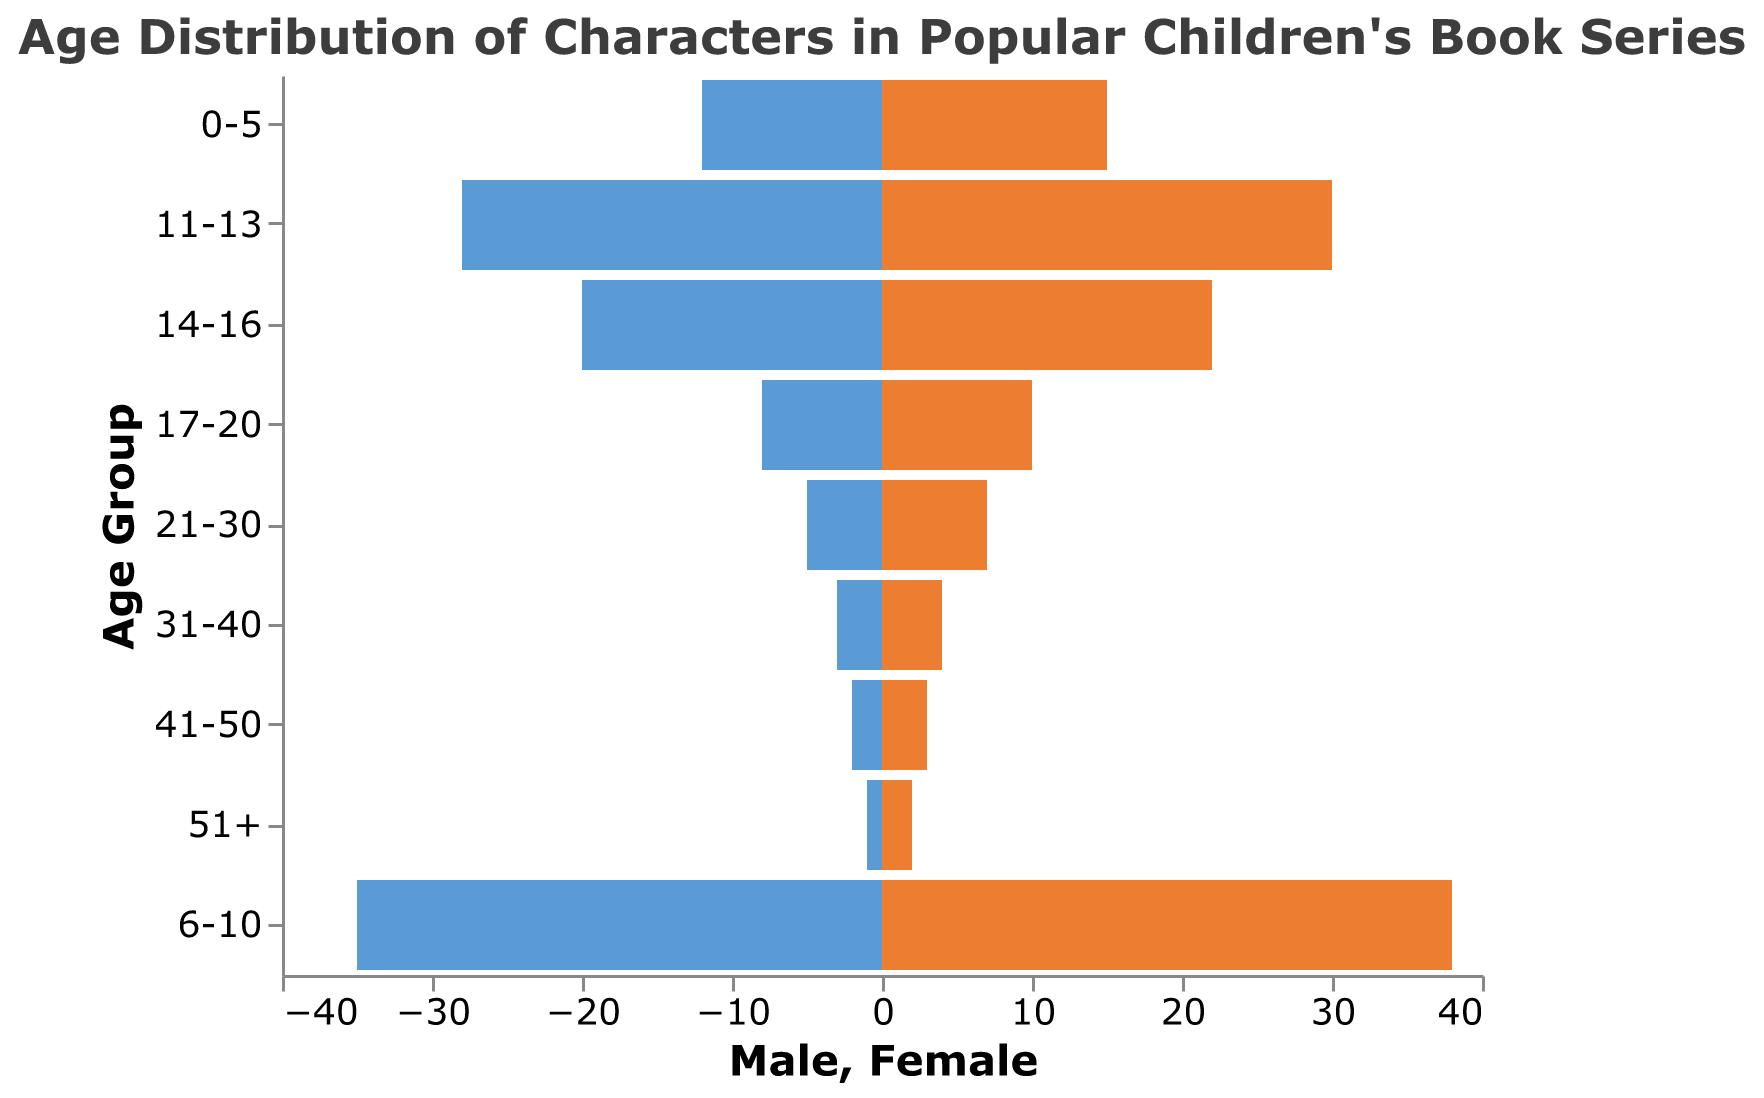What are the colors used to represent male and female characters? The plot shows bars with two distinct colors: one color for male characters and another color for female characters. The male characters are represented by blue bars while female characters are represented by orange bars.
Answer: Blue for male and orange for female How many age groups are there in the figure? The y-axis of the plot lists the age groups. By counting each unique group presented on the y-axis, you can determine the total number of age groups.
Answer: 9 Which age group has the highest number of female characters? To find the age group with the highest number of female characters, look at the length of the orange bars corresponding to each age group. The longest orange bar represents the age group with the most female characters.
Answer: 6-10 What is the total number of characters (male and female) in the 14-16 age group? Look at the 14-16 age group and note the number of male (20) and female (22) characters. Add these two numbers to get the total.
Answer: 42 Which age group has the smallest number of characters in total? To determine the age group with the smallest number of characters, add the numbers of male and female characters for each age group and find the group with the smallest sum.
Answer: 51+ How many more female characters are there than male characters in the 0-5 age group? Identify the number of male (12) and female (15) characters in the 0-5 age group, then subtract the number of male characters from the number of female characters.
Answer: 3 Which gender has more characters aged 17-20? Compare the lengths of the bars (numbers) for male (8) and female (10) characters in the 17-20 age group.
Answer: Female What proportion of all characters are in the 6-10 age group? Sum the number of male (35) and female (38) characters in the 6-10 age group to get the total number in this age group. Then, sum all characters across all groups (subtract male values from zero to make them positive): (12 + 15 + 35 + 38 + 28 + 30 + 20 + 22 + 8 + 10 + 5 + 7 + 3 + 4 + 2 + 3 + 1 + 2 = 245). The proportion is (35 + 38) / 245.
Answer: Approximately 29.8% What is the most common age group for male characters? Look at the lengths of the blue bars across all age groups and determine the age group with the longest blue bar.
Answer: 6-10 